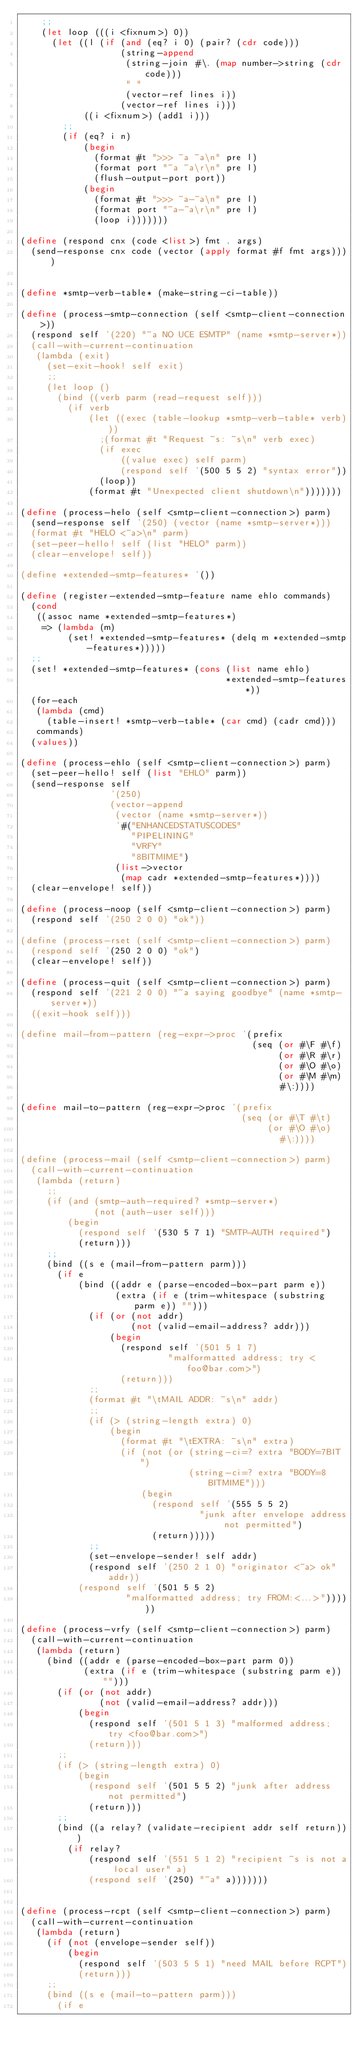<code> <loc_0><loc_0><loc_500><loc_500><_Scheme_>    ;;
    (let loop (((i <fixnum>) 0))
      (let ((l (if (and (eq? i 0) (pair? (cdr code)))
                   (string-append
                    (string-join #\. (map number->string (cdr code)))
                    " "
                    (vector-ref lines i))
                   (vector-ref lines i)))
            ((i <fixnum>) (add1 i)))
        ;;
        (if (eq? i n)
            (begin
              (format #t ">>> ~a ~a\n" pre l)
              (format port "~a ~a\r\n" pre l)
              (flush-output-port port))
            (begin
              (format #t ">>> ~a-~a\n" pre l)
              (format port "~a-~a\r\n" pre l)
              (loop i)))))))

(define (respond cnx (code <list>) fmt . args)
  (send-response cnx code (vector (apply format #f fmt args))))


(define *smtp-verb-table* (make-string-ci-table))

(define (process-smtp-connection (self <smtp-client-connection>))
  (respond self '(220) "~a NO UCE ESMTP" (name *smtp-server*))
  (call-with-current-continuation
   (lambda (exit)
     (set-exit-hook! self exit)
     ;;
     (let loop ()
       (bind ((verb parm (read-request self)))
         (if verb
             (let ((exec (table-lookup *smtp-verb-table* verb)))
               ;(format #t "Request ~s: ~s\n" verb exec)
               (if exec
                   ((value exec) self parm)
                   (respond self '(500 5 5 2) "syntax error"))
               (loop))
             (format #t "Unexpected client shutdown\n")))))))

(define (process-helo (self <smtp-client-connection>) parm)
  (send-response self '(250) (vector (name *smtp-server*)))
  (format #t "HELO <~a>\n" parm)
  (set-peer-hello! self (list "HELO" parm))
  (clear-envelope! self))

(define *extended-smtp-features* '())

(define (register-extended-smtp-feature name ehlo commands)
  (cond
   ((assoc name *extended-smtp-features*)
    => (lambda (m)
         (set! *extended-smtp-features* (delq m *extended-smtp-features*)))))
  ;;
  (set! *extended-smtp-features* (cons (list name ehlo)
                                       *extended-smtp-features*))
  (for-each
   (lambda (cmd)
     (table-insert! *smtp-verb-table* (car cmd) (cadr cmd)))
   commands)
  (values))

(define (process-ehlo (self <smtp-client-connection>) parm)
  (set-peer-hello! self (list "EHLO" parm))
  (send-response self
                 '(250)
                 (vector-append 
                  (vector (name *smtp-server*))
                  '#("ENHANCEDSTATUSCODES"
                     "PIPELINING"
                     "VRFY"
                     "8BITMIME")
                  (list->vector 
                   (map cadr *extended-smtp-features*))))
  (clear-envelope! self))

(define (process-noop (self <smtp-client-connection>) parm)
  (respond self '(250 2 0 0) "ok"))

(define (process-rset (self <smtp-client-connection>) parm)
  (respond self '(250 2 0 0) "ok")
  (clear-envelope! self))

(define (process-quit (self <smtp-client-connection>) parm)
  (respond self '(221 2 0 0) "~a saying goodbye" (name *smtp-server*))
  ((exit-hook self)))

(define mail-from-pattern (reg-expr->proc '(prefix
                                            (seq (or #\F #\f)
                                                 (or #\R #\r)
                                                 (or #\O #\o)
                                                 (or #\M #\m)
                                                 #\:))))

(define mail-to-pattern (reg-expr->proc '(prefix
                                          (seq (or #\T #\t)
                                               (or #\O #\o)
                                                 #\:))))

(define (process-mail (self <smtp-client-connection>) parm)
  (call-with-current-continuation
   (lambda (return)
     ;;
     (if (and (smtp-auth-required? *smtp-server*)
              (not (auth-user self)))
         (begin
           (respond self '(530 5 7 1) "SMTP-AUTH required")
           (return)))
     ;;
     (bind ((s e (mail-from-pattern parm)))
       (if e
           (bind ((addr e (parse-encoded-box-part parm e))
                  (extra (if e (trim-whitespace (substring parm e)) "")))
             (if (or (not addr)
                     (not (valid-email-address? addr)))
                 (begin
                   (respond self '(501 5 1 7)
                            "malformatted address; try <foo@bar.com>")
                   (return)))
             ;;
             (format #t "\tMAIL ADDR: ~s\n" addr)
             ;;
             (if (> (string-length extra) 0)
                 (begin
                   (format #t "\tEXTRA: ~s\n" extra)
                   (if (not (or (string-ci=? extra "BODY=7BIT")
                                (string-ci=? extra "BODY=8BITMIME")))
                       (begin
                         (respond self '(555 5 5 2)
                                  "junk after envelope address not permitted")
                         (return)))))
             ;;
             (set-envelope-sender! self addr)
             (respond self '(250 2 1 0) "originator <~a> ok" addr))
           (respond self '(501 5 5 2)
                    "malformatted address; try FROM:<...>"))))))

(define (process-vrfy (self <smtp-client-connection>) parm)
  (call-with-current-continuation
   (lambda (return)
     (bind ((addr e (parse-encoded-box-part parm 0))
            (extra (if e (trim-whitespace (substring parm e)) "")))
       (if (or (not addr)
               (not (valid-email-address? addr)))
           (begin
             (respond self '(501 5 1 3) "malformed address; try <foo@bar.com>")
             (return)))
       ;;
       (if (> (string-length extra) 0)
           (begin
             (respond self '(501 5 5 2) "junk after address not permitted")
             (return)))
       ;;
       (bind ((a relay? (validate-recipient addr self return)))
         (if relay?
             (respond self '(551 5 1 2) "recipient ~s is not a local user" a)
             (respond self '(250) "~a" a)))))))

  
(define (process-rcpt (self <smtp-client-connection>) parm)
  (call-with-current-continuation
   (lambda (return)
     (if (not (envelope-sender self))
         (begin
           (respond self '(503 5 5 1) "need MAIL before RCPT")
           (return)))
     ;;
     (bind ((s e (mail-to-pattern parm)))
       (if e</code> 